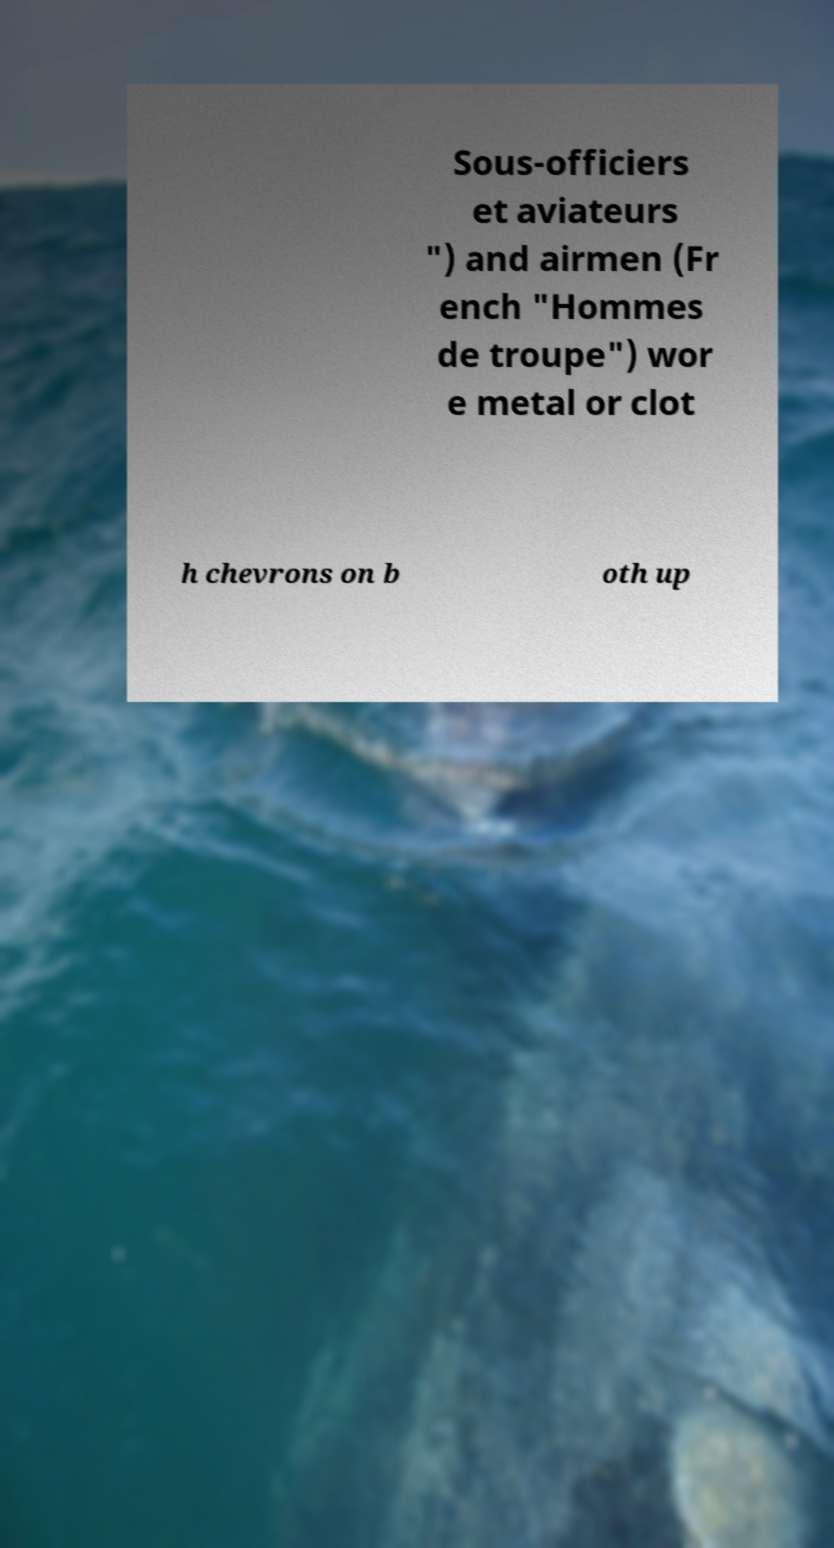Can you accurately transcribe the text from the provided image for me? Sous-officiers et aviateurs ") and airmen (Fr ench "Hommes de troupe") wor e metal or clot h chevrons on b oth up 